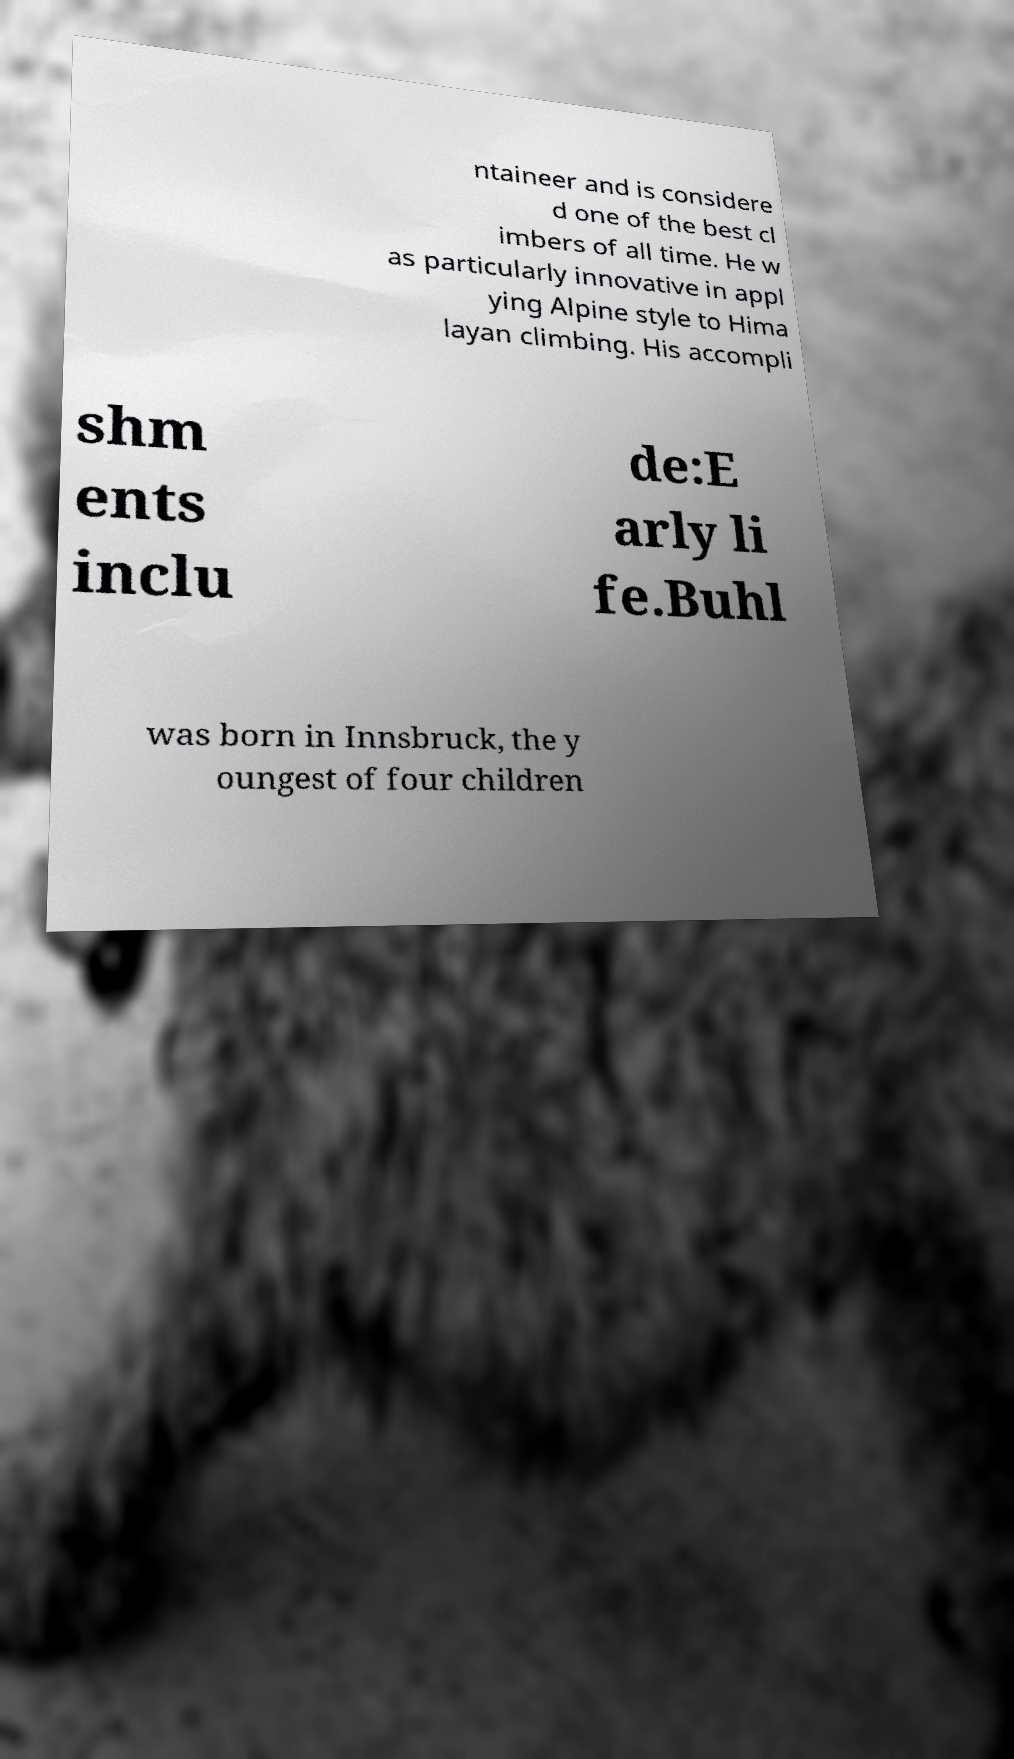Can you read and provide the text displayed in the image?This photo seems to have some interesting text. Can you extract and type it out for me? ntaineer and is considere d one of the best cl imbers of all time. He w as particularly innovative in appl ying Alpine style to Hima layan climbing. His accompli shm ents inclu de:E arly li fe.Buhl was born in Innsbruck, the y oungest of four children 